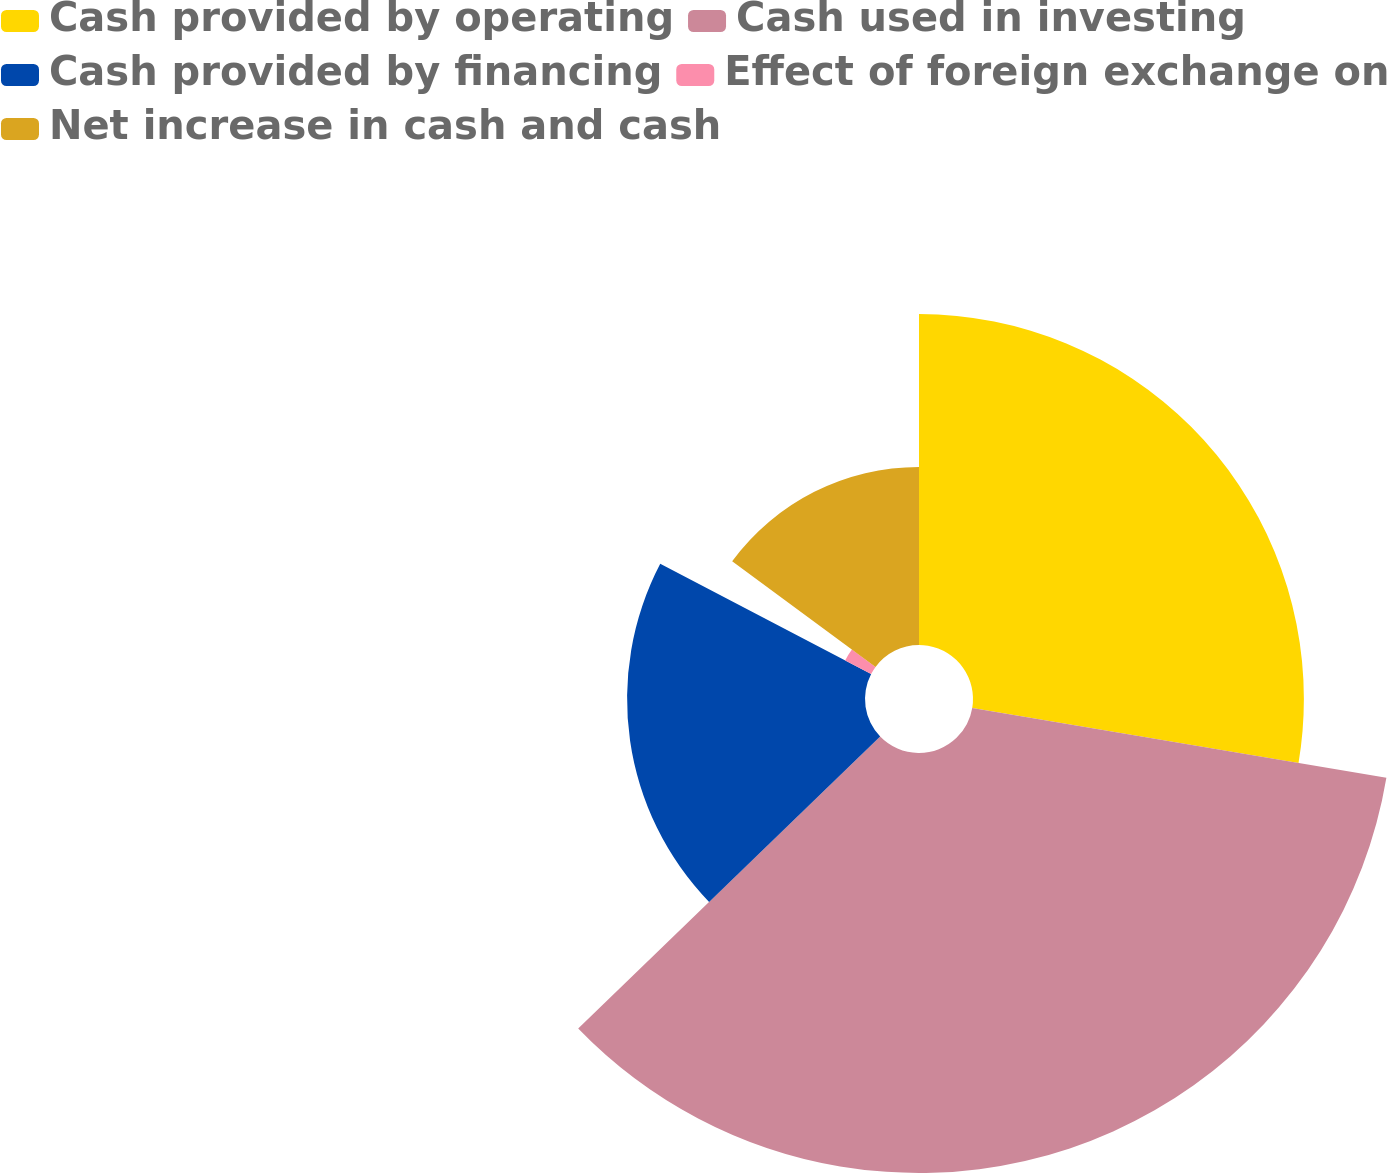Convert chart to OTSL. <chart><loc_0><loc_0><loc_500><loc_500><pie_chart><fcel>Cash provided by operating<fcel>Cash used in investing<fcel>Cash provided by financing<fcel>Effect of foreign exchange on<fcel>Net increase in cash and cash<nl><fcel>27.66%<fcel>35.11%<fcel>19.89%<fcel>2.45%<fcel>14.89%<nl></chart> 